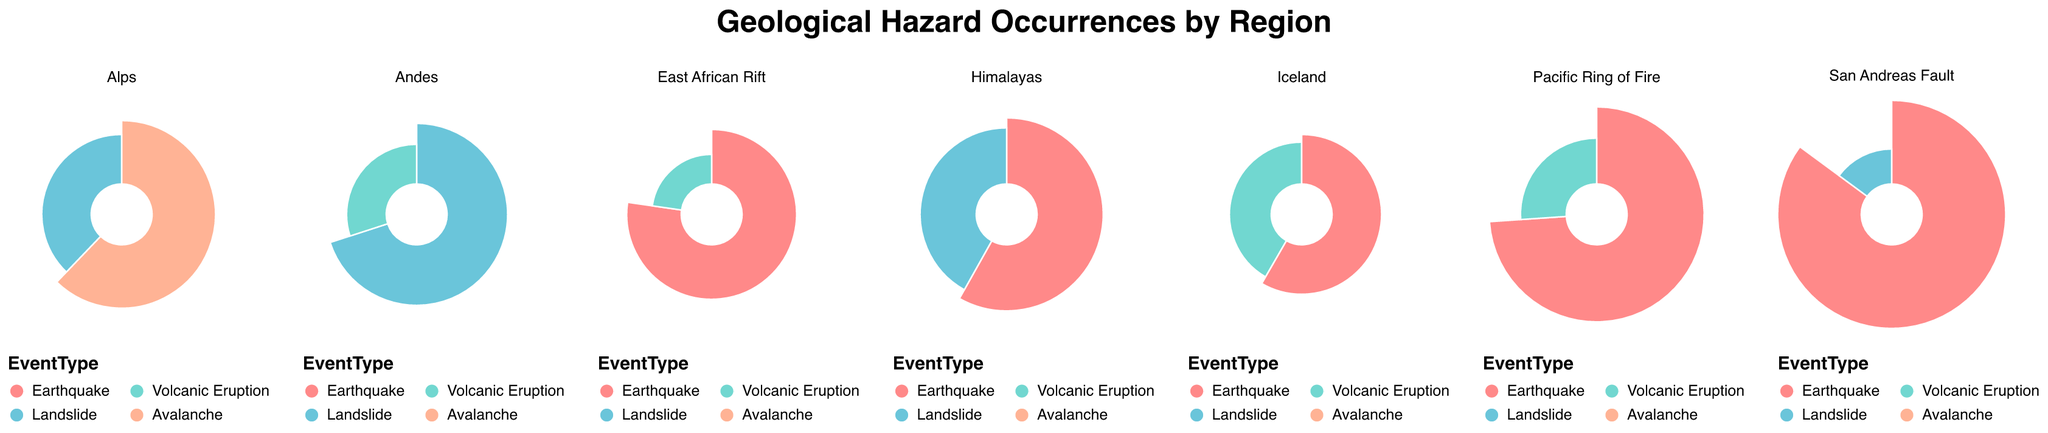Which region has the highest frequency of earthquakes? According to the data in the figure, the region with the highest frequency of earthquakes is San Andreas Fault, with a frequency of 40.
Answer: San Andreas Fault What is the total frequency of landslides across all regions? To find this, we need to add up the frequencies of landslides in Andes (21), Himalayas (18), San Andreas Fault (7), and Alps (14), which totals 60.
Answer: 60 Which geological event in the Pacific Ring of Fire has the highest frequency? The figure shows that in the Pacific Ring of Fire, the earthquake has a frequency of 34, whereas volcanic eruption has a frequency of 12. Therefore, earthquake has the highest frequency.
Answer: Earthquake How does the frequency of earthquakes in the Himalayas compare to those in the East African Rift? The figure indicates that the frequency of earthquakes in the Himalayas is 25, while in the East African Rift it is 17. Comparing these two values, the Himalayas have more frequent earthquakes than the East African Rift.
Answer: Himalayas What's the aggregate frequency of volcanic eruptions in the Andes and Iceland? The figure shows that the Andes have a frequency of 9 for volcanic eruptions, and Iceland has a frequency of 10 for volcanic eruptions. Adding these together gives us an aggregate frequency of 19.
Answer: 19 Which region experiences both earthquakes and volcanic eruptions but has more volcanic eruptions than earthquakes? From the figure, regions such as the East African Rift and Pacific Ring of Fire have both earthquakes and volcanic eruptions. However, neither of these regions has more volcanic eruptions than earthquakes. Thus, no such region exists.
Answer: None How do the frequencies of geological events (earthquake, volcanic eruption, landslide) in the Pacific Ring of Fire and Andes compare? In the Pacific Ring of Fire, the frequencies are: Earthquake (34) and Volcanic Eruption (12). In the Andes, they are: Landslide (21) and Volcanic Eruption (9). Comparing them:
- Earthquake: Pacific Ring of Fire (34) vs. Andes (0)
- Volcanic Eruption: Pacific Ring of Fire (12) vs. Andes (9)
- Landslide: Pacific Ring of Fire (0) vs. Andes (21)
Answer: The Pacific Ring of Fire has more earthquakes and volcanic eruptions than the Andes, but the Andes have more landslides Which region has the highest combined frequency of geological events? To determine the region with the highest combined frequency, we sum the frequencies for each region:
- Pacific Ring of Fire: 34 (Earthquake) + 12 (Volcanic Eruption) = 46
- Andes: 21 (Landslide) + 9 (Volcanic Eruption) = 30
- Himalayas: 25 (Earthquake) + 18 (Landslide) = 43
- San Andreas Fault: 40 (Earthquake) + 7 (Landslide) = 47
- Iceland: 10 (Volcanic Eruption) + 14 (Earthquake) = 24
- Alps: 23 (Avalanche) + 14 (Landslide) = 37
- East African Rift: 17 (Earthquake) + 5 (Volcanic Eruption) = 22
The region with the highest combined frequency is San Andreas Fault with 47.
Answer: San Andreas Fault What is the most common type of geological event in the Alps? The figure shows that the Alps have an avalanche occurring 23 times and a landslide occurring 14 times. Therefore, avalanche is the most common type of geological event in the Alps.
Answer: Avalanche 